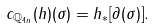<formula> <loc_0><loc_0><loc_500><loc_500>c _ { \mathbb { Q } _ { 4 n } } ( h ) ( \sigma ) = h _ { \ast } [ \partial ( \sigma ) ] .</formula> 